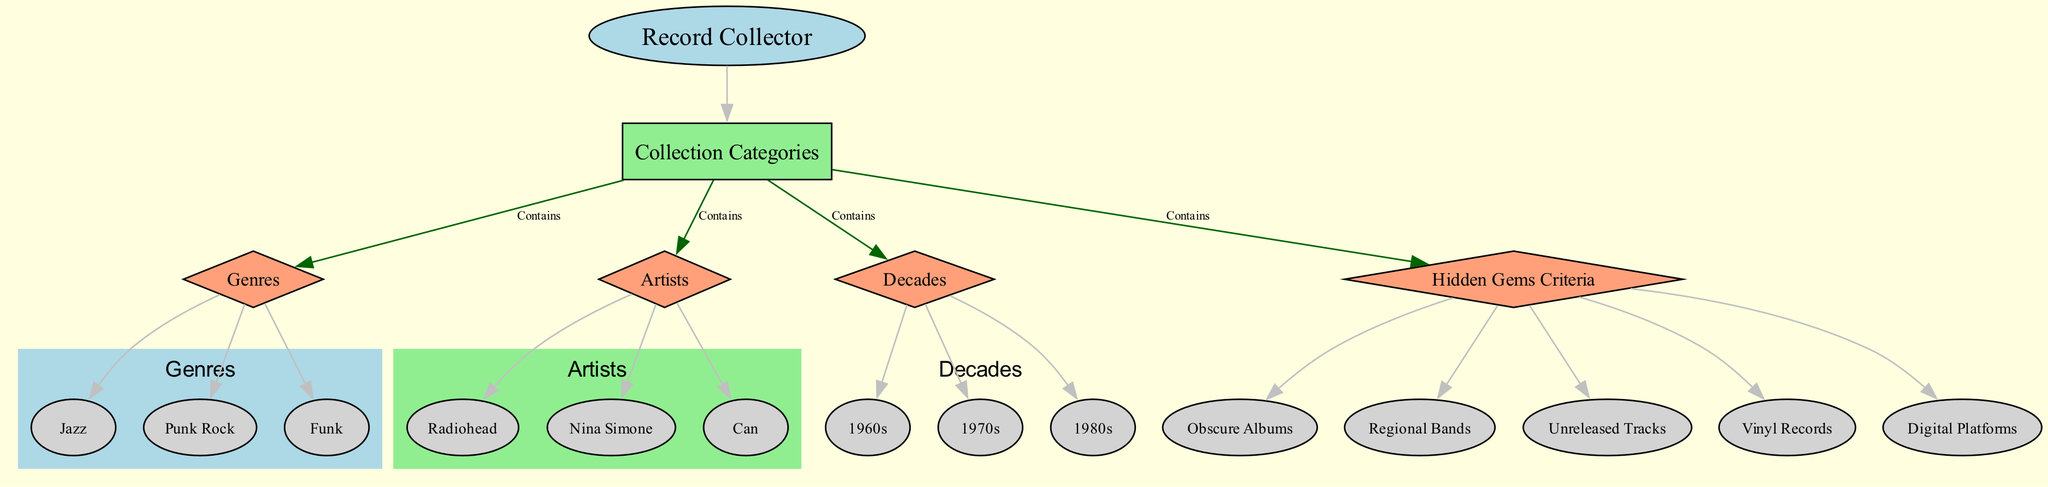What is the main entity represented in the diagram? The diagram begins with the node labeled "Record Collector," indicating it is the primary subject or main entity around which the recommendations are structured.
Answer: Record Collector How many categories are shown in the collection? The node labeled "Collection Categories" branches into four distinct nodes: Genres, Artists, Decades, and Hidden Gems Criteria. Thus, there are four categories represented.
Answer: 4 Which genre appears at the bottom of the genres section? From the "Genres" node, the downward connections lead to three genre nodes: Jazz, Punk Rock, and Funk. Since "Funk" is last in this layout, it is the answer.
Answer: Funk What type of records is mentioned under Hidden Gems Criteria? The "Hidden Gems Criteria" node connects to several items, one of which is "Vinyl Records." This indicates that vinyl records are a specific type mentioned in this context.
Answer: Vinyl Records Name one artist listed in the artists section. The "Artists" node connects to three specific artist nodes: Radiohead, Nina Simone, and Can. Any of these can be an answer, but I will take "Radiohead" as an example.
Answer: Radiohead Which decade has a node connected to the Collection Categories? Under the "Decades" node, three decade nodes are connected: 1960s, 1970s, and 1980s. One of these decades can be chosen, so I'll refer to the earliest, "1960s."
Answer: 1960s What is the connection between the "Record Collector" and "Hidden Gems Criteria"? The "Record Collector" has a direct link to "Collection Categories," which in turn connects to "Hidden Gems Criteria." Thus, the relationship is that the record collector organizes their collection based on hidden gems.
Answer: Contains How many different types of hidden gems are specified within the criteria? The "Hidden Gems Criteria" node has three direct connections leading to Obscure Albums, Regional Bands, and Unreleased Tracks, indicating three specific types of hidden gems are identified.
Answer: 3 What color is used to represent the main node in the diagram? The "Record Collector" node, which is the main subject, is filled with light blue color in the diagram to distinguish it as the primary focus.
Answer: Light Blue 